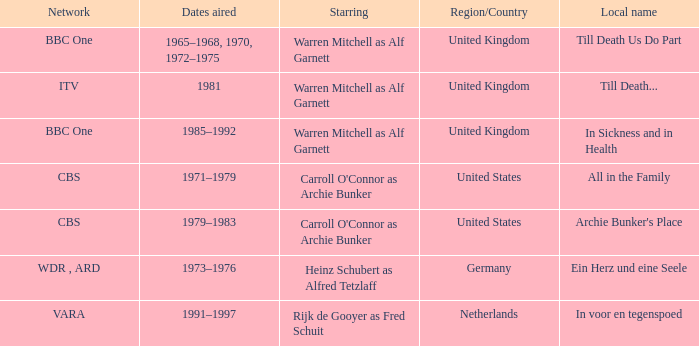What is the local name for the episodes that aired in 1981? Till Death... 